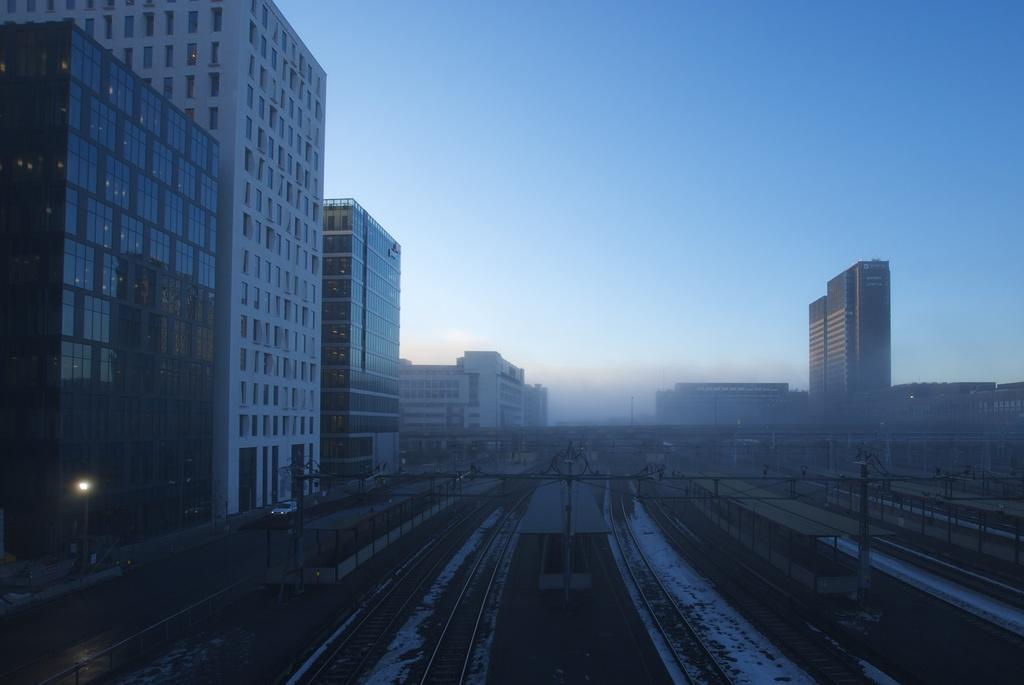What type of transportation infrastructure is visible in the image? There are railway tracks and platforms in the image. What other structures can be seen in the image? There are poles, buildings, and light poles in the image. What is happening on the road in the image? Vehicles are moving on the road in the image. What can be seen in the background of the image? The sky is visible in the background of the image. What type of fang can be seen in the image? There is no fang present in the image. How much sugar is visible in the image? There is no sugar present in the image. 